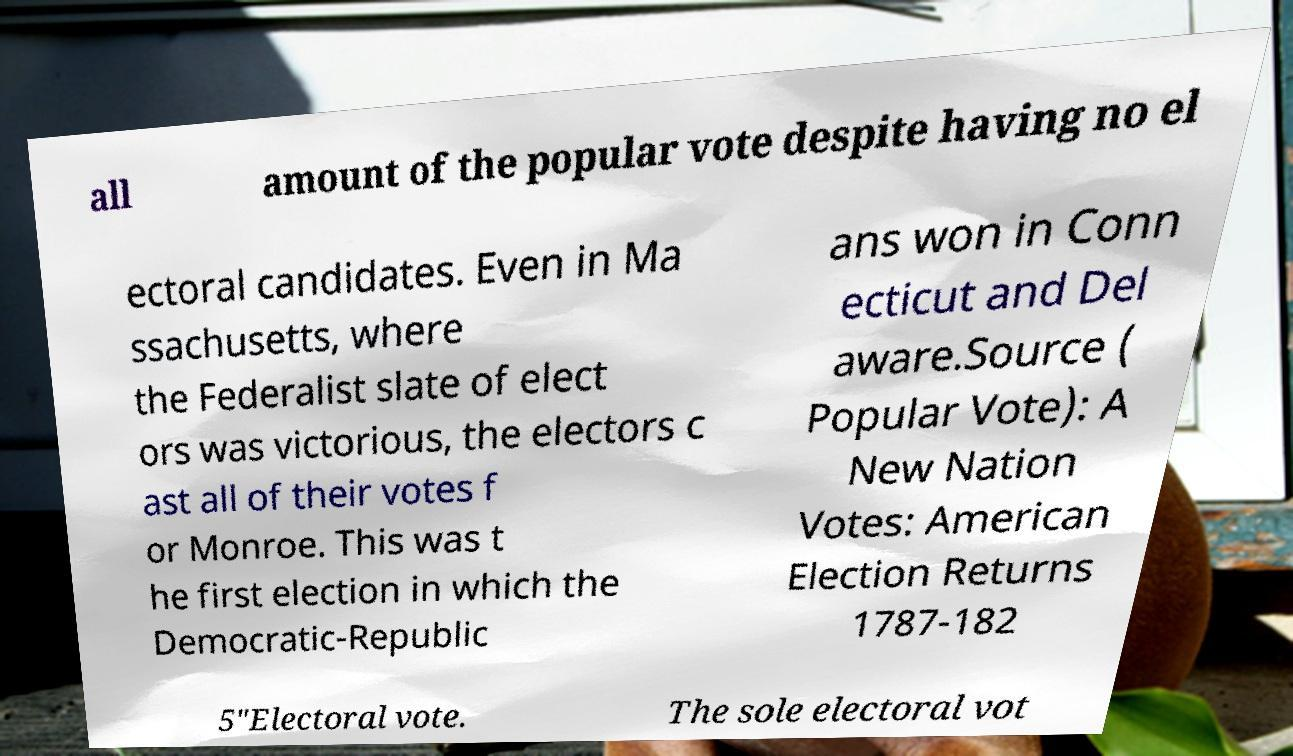What messages or text are displayed in this image? I need them in a readable, typed format. all amount of the popular vote despite having no el ectoral candidates. Even in Ma ssachusetts, where the Federalist slate of elect ors was victorious, the electors c ast all of their votes f or Monroe. This was t he first election in which the Democratic-Republic ans won in Conn ecticut and Del aware.Source ( Popular Vote): A New Nation Votes: American Election Returns 1787-182 5"Electoral vote. The sole electoral vot 